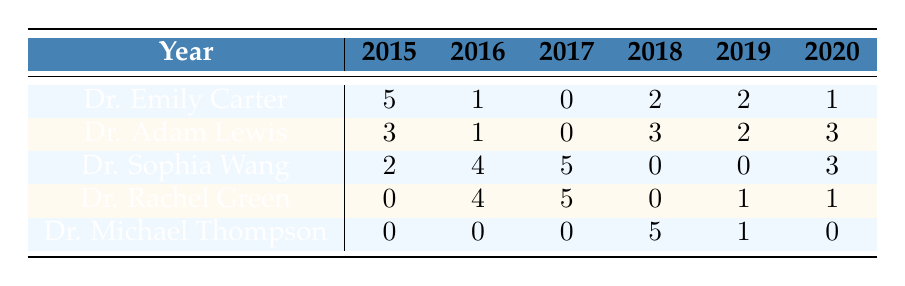What is the total publication count for Dr. Emily Carter across all years? To find the total for Dr. Emily Carter, sum the publication counts listed in her row: 5 (2015) + 1 (2016) + 0 (2017) + 2 (2018) + 2 (2019) + 1 (2020) = 11.
Answer: 11 In which year did Dr. Rachel Green collaborate the most, according to the publication counts? Dr. Rachel Green has the highest collaboration count in 2017 with 5 publications. Comparing all the values in her row, 0 (2015), 4 (2016), 5 (2017), 0 (2018), 1 (2019), and 1 (2020), the maximum is 5 in 2017.
Answer: 2017 Did Dr. Sophia Wang have any publications in 2018? According to the table, Dr. Sophia Wang has 0 publications in 2018 as shown in her row for that year.
Answer: No What is the average number of publications for Dr. Adam Lewis over the years he collaborated? The publication counts for Dr. Adam Lewis are: 3 (2015), 1 (2016), 0 (2017), 3 (2018), 2 (2019), and 3 (2020). The total is 3 + 1 + 0 + 3 + 2 + 3 = 12. There are 6 data points, so the average is 12 / 6 = 2.
Answer: 2 Which researcher had the highest total publication count in 2016? In 2016, Dr. Sophia Wang leads with 4 publications, as seen in her row. Comparing other researchers: Dr. Emily Carter has 1, Dr. Adam Lewis has 1, Dr. Rachel Green has 4, and Dr. Michael Thompson has 0. Dr. Sophia Wang and Dr. Rachel Green are tied, but per the inquiry for maximum publication count, we conclude that 4 publications is the highest for either.
Answer: Dr. Sophia Wang What is the difference in total publications between Dr. Michael Thompson and Dr. Rachel Green across all years? For Dr. Michael Thompson, the publication counts are 0 (2015), 0 (2016), 0 (2017), 5 (2018), 1 (2019), 0 (2020), totaling 6. For Dr. Rachel Green, the counts are 0 (2015), 4 (2016), 5 (2017), 0 (2018), 1 (2019), and 1 (2020), totaling 11. The difference is 11 - 6 = 5.
Answer: 5 